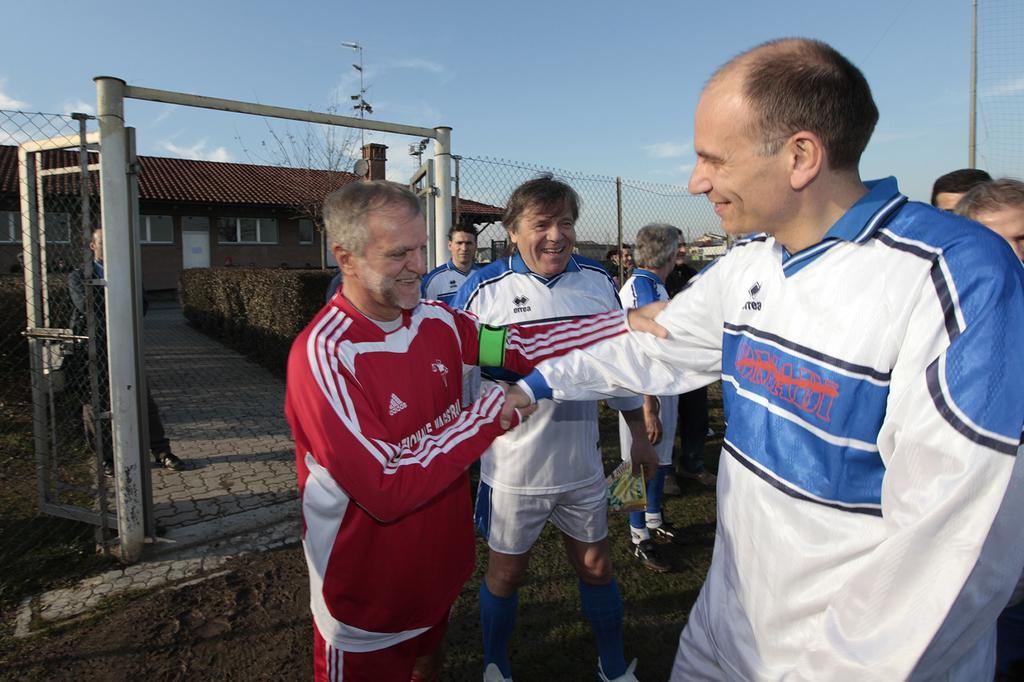Provide a one-sentence caption for the provided image. A man, wearing a red Adidas jacket, shakes hands with another man. 